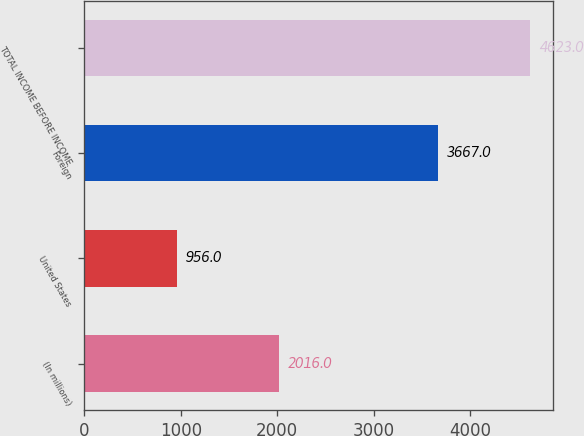Convert chart. <chart><loc_0><loc_0><loc_500><loc_500><bar_chart><fcel>(In millions)<fcel>United States<fcel>Foreign<fcel>TOTAL INCOME BEFORE INCOME<nl><fcel>2016<fcel>956<fcel>3667<fcel>4623<nl></chart> 